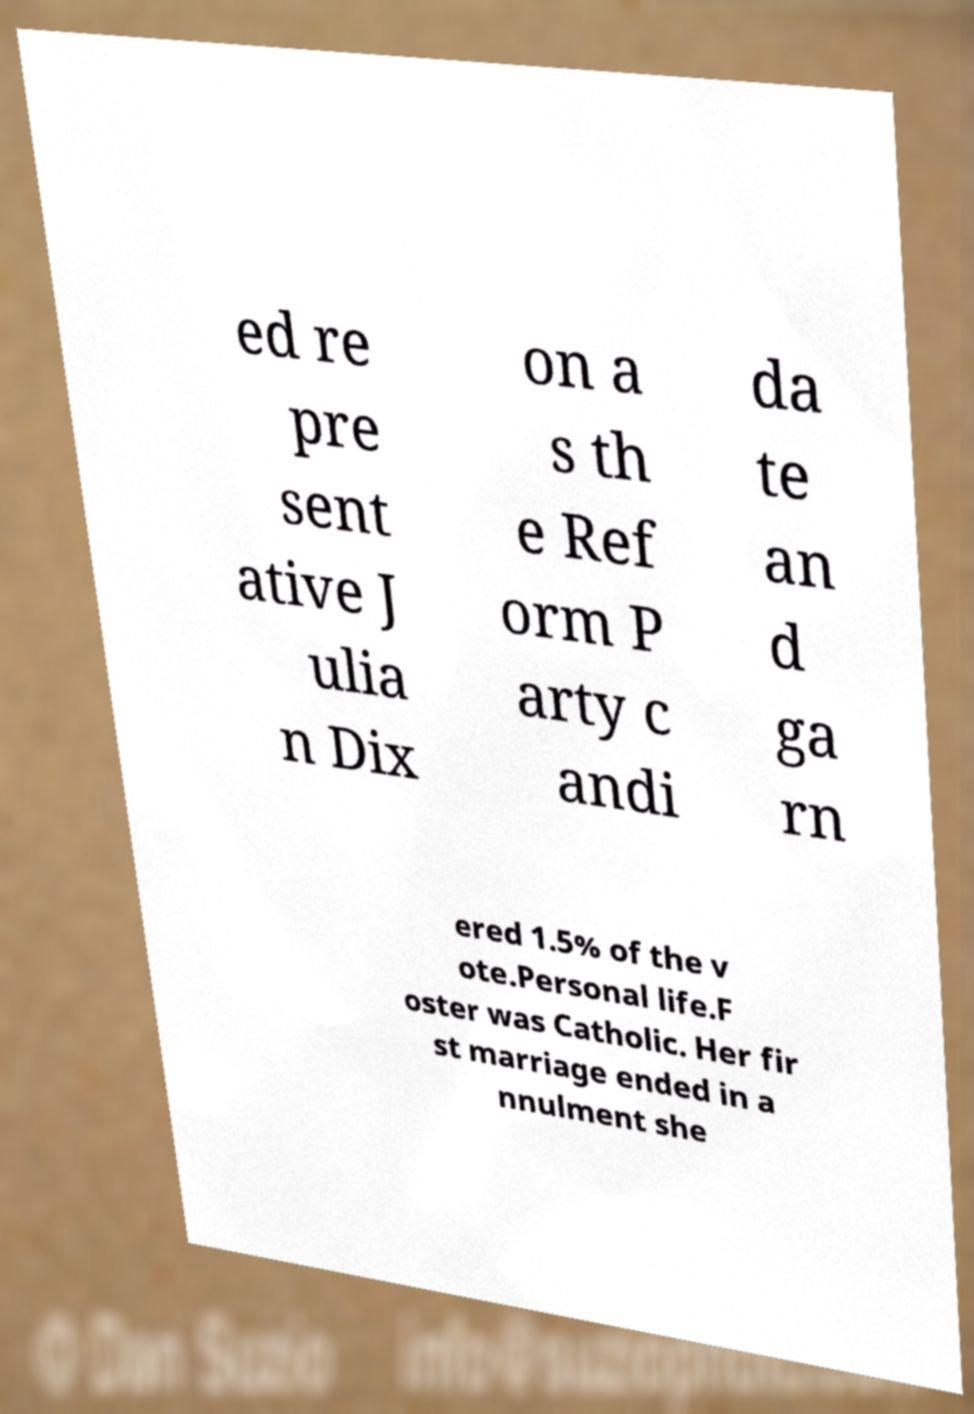There's text embedded in this image that I need extracted. Can you transcribe it verbatim? ed re pre sent ative J ulia n Dix on a s th e Ref orm P arty c andi da te an d ga rn ered 1.5% of the v ote.Personal life.F oster was Catholic. Her fir st marriage ended in a nnulment she 